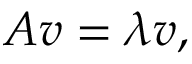Convert formula to latex. <formula><loc_0><loc_0><loc_500><loc_500>A v = \lambda v ,</formula> 